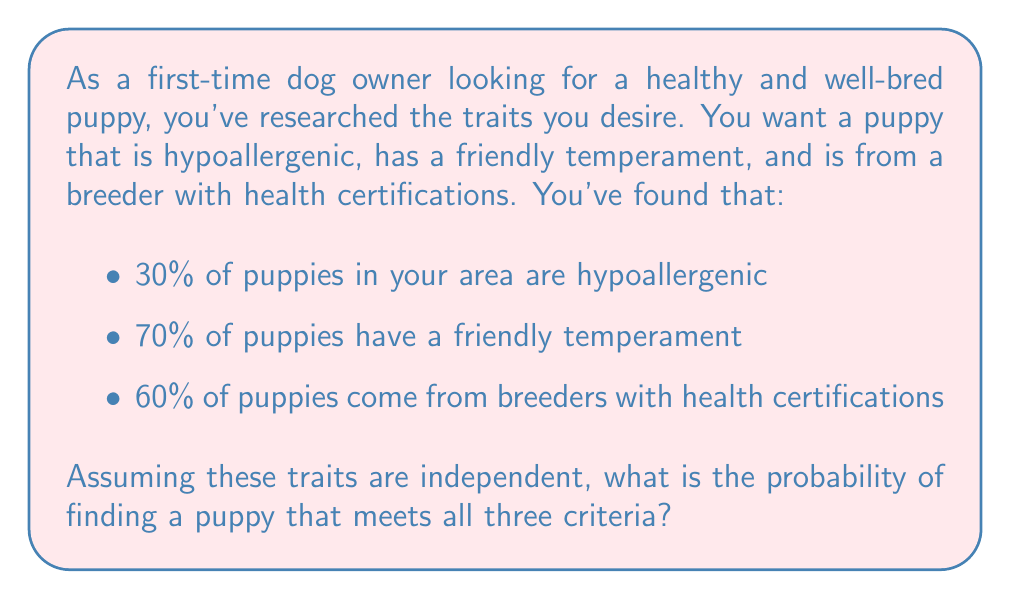Help me with this question. To solve this problem, we need to use the multiplication rule of probability for independent events. Since we're assuming the traits are independent, we can multiply the individual probabilities to find the probability of all three traits occurring together.

Let's define our events:
- A: Puppy is hypoallergenic (P(A) = 0.30)
- B: Puppy has a friendly temperament (P(B) = 0.70)
- C: Puppy comes from a breeder with health certifications (P(C) = 0.60)

We want to find P(A ∩ B ∩ C), which is the probability of all three events occurring together.

For independent events:

$$ P(A \cap B \cap C) = P(A) \times P(B) \times P(C) $$

Substituting our values:

$$ P(A \cap B \cap C) = 0.30 \times 0.70 \times 0.60 $$

Calculating:

$$ P(A \cap B \cap C) = 0.126 $$

To convert to a percentage, we multiply by 100:

$$ 0.126 \times 100 = 12.6\% $$

Therefore, the probability of finding a puppy that meets all three criteria is 12.6% or approximately 1 in 8 puppies.
Answer: The probability of finding a puppy with all three desired traits is 12.6% or 0.126. 